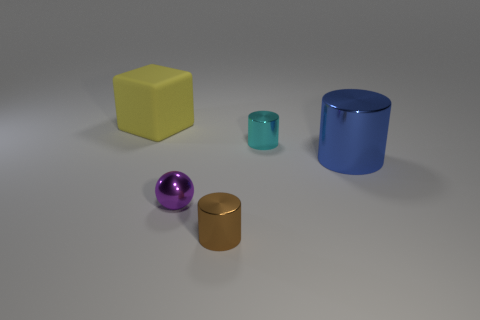Is there any other thing that is made of the same material as the big yellow thing?
Give a very brief answer. No. What color is the tiny metal object behind the large object that is in front of the big yellow thing?
Make the answer very short. Cyan. There is a object that is left of the small cyan cylinder and behind the large blue shiny cylinder; what is its material?
Offer a terse response. Rubber. Is there a purple object of the same size as the cyan shiny thing?
Give a very brief answer. Yes. There is a yellow object that is the same size as the blue thing; what is its material?
Offer a very short reply. Rubber. There is a large matte thing; how many metallic balls are in front of it?
Your answer should be very brief. 1. Does the big thing that is to the right of the yellow matte object have the same shape as the brown shiny thing?
Offer a terse response. Yes. Are there any big blue things that have the same shape as the brown metal object?
Your answer should be very brief. Yes. There is a large object to the left of the big thing right of the tiny ball; what is its shape?
Make the answer very short. Cube. What number of tiny brown objects are the same material as the big cylinder?
Provide a succinct answer. 1. 